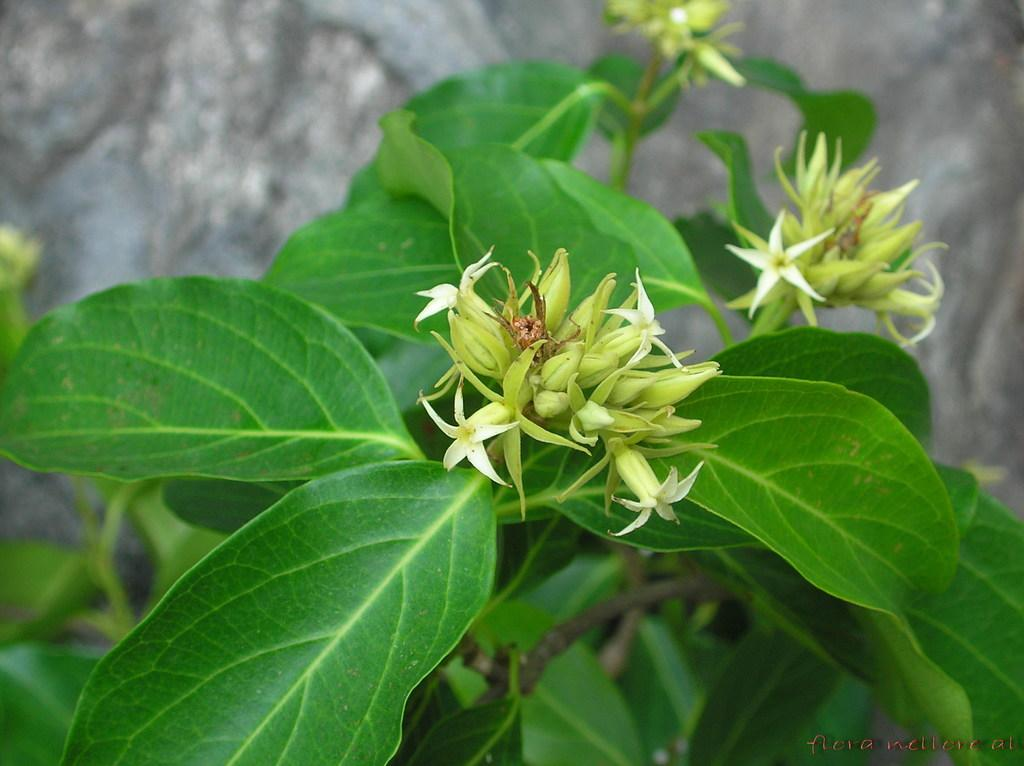What is present in the picture? There is a plant in the picture. What can be observed about the leaves of the plant? The plant has green leaves. What type of flowers are on the plant? The plant has white flowers. What is the name of the person holding the plant in the image? There is no person holding the plant in the image; it is a static picture of the plant itself. 